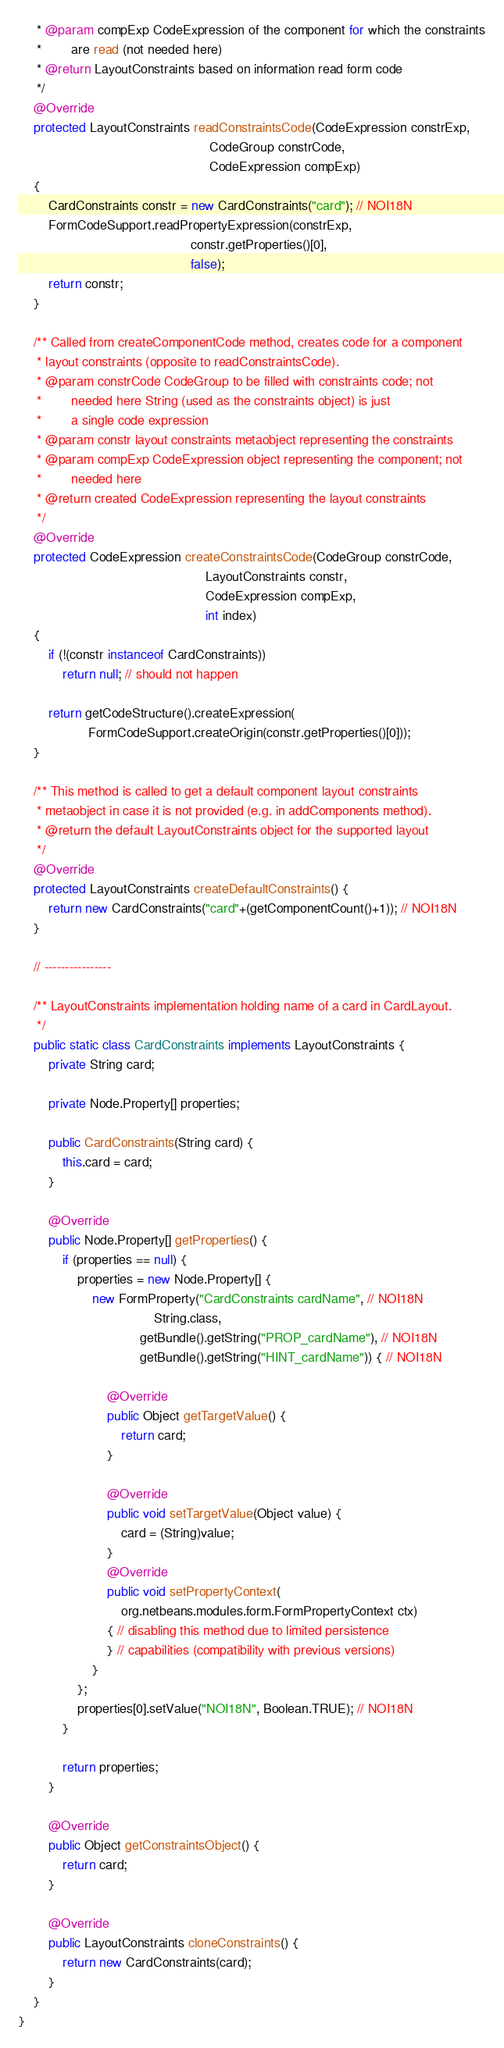<code> <loc_0><loc_0><loc_500><loc_500><_Java_>     * @param compExp CodeExpression of the component for which the constraints
     *        are read (not needed here)
     * @return LayoutConstraints based on information read form code
     */
    @Override
    protected LayoutConstraints readConstraintsCode(CodeExpression constrExp,
                                                    CodeGroup constrCode,
                                                    CodeExpression compExp)
    {
        CardConstraints constr = new CardConstraints("card"); // NOI18N
        FormCodeSupport.readPropertyExpression(constrExp,
                                               constr.getProperties()[0],
                                               false);
        return constr;
    }

    /** Called from createComponentCode method, creates code for a component
     * layout constraints (opposite to readConstraintsCode).
     * @param constrCode CodeGroup to be filled with constraints code; not
     *        needed here String (used as the constraints object) is just
     *        a single code expression
     * @param constr layout constraints metaobject representing the constraints
     * @param compExp CodeExpression object representing the component; not
     *        needed here
     * @return created CodeExpression representing the layout constraints
     */
    @Override
    protected CodeExpression createConstraintsCode(CodeGroup constrCode,
                                                   LayoutConstraints constr,
                                                   CodeExpression compExp,
                                                   int index)
    {
        if (!(constr instanceof CardConstraints))
            return null; // should not happen

        return getCodeStructure().createExpression(
                   FormCodeSupport.createOrigin(constr.getProperties()[0]));
    }

    /** This method is called to get a default component layout constraints
     * metaobject in case it is not provided (e.g. in addComponents method).
     * @return the default LayoutConstraints object for the supported layout
     */
    @Override
    protected LayoutConstraints createDefaultConstraints() {
        return new CardConstraints("card"+(getComponentCount()+1)); // NOI18N
    }

    // ----------------

    /** LayoutConstraints implementation holding name of a card in CardLayout.
     */
    public static class CardConstraints implements LayoutConstraints {
        private String card;

        private Node.Property[] properties;

        public CardConstraints(String card) {
            this.card = card;
        }

        @Override
        public Node.Property[] getProperties() {
            if (properties == null) {
                properties = new Node.Property[] {
                    new FormProperty("CardConstraints cardName", // NOI18N
                                     String.class,
                                 getBundle().getString("PROP_cardName"), // NOI18N
                                 getBundle().getString("HINT_cardName")) { // NOI18N

                        @Override
                        public Object getTargetValue() {
                            return card;
                        }

                        @Override
                        public void setTargetValue(Object value) {
                            card = (String)value;
                        }
                        @Override
                        public void setPropertyContext(
                            org.netbeans.modules.form.FormPropertyContext ctx)
                        { // disabling this method due to limited persistence
                        } // capabilities (compatibility with previous versions)
                    }
                };
                properties[0].setValue("NOI18N", Boolean.TRUE); // NOI18N
            }

            return properties;
        }

        @Override
        public Object getConstraintsObject() {
            return card;
        }

        @Override
        public LayoutConstraints cloneConstraints() {
            return new CardConstraints(card);
        }
    }
}
</code> 